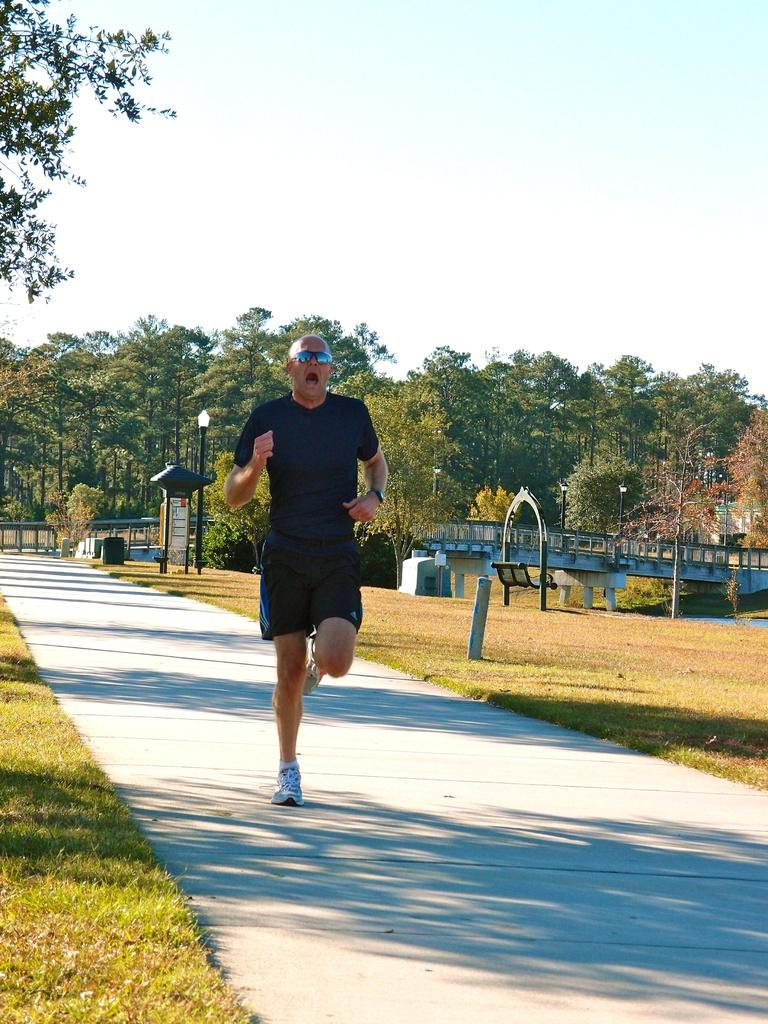What is the man in the image doing? The man is running in the image. On what surface is the man running? The man is running on the floor. What can be seen in the background of the image? In the background of the image, there are clouds in the sky, trees, a bridge, a bench, street poles, street lights, and bins. What type of branch is the man using to swing across the street in the image? There is no branch present in the image, and the man is running, not swinging across the street. How is the hook attached to the beam in the image? There is no hook or beam present in the image. 